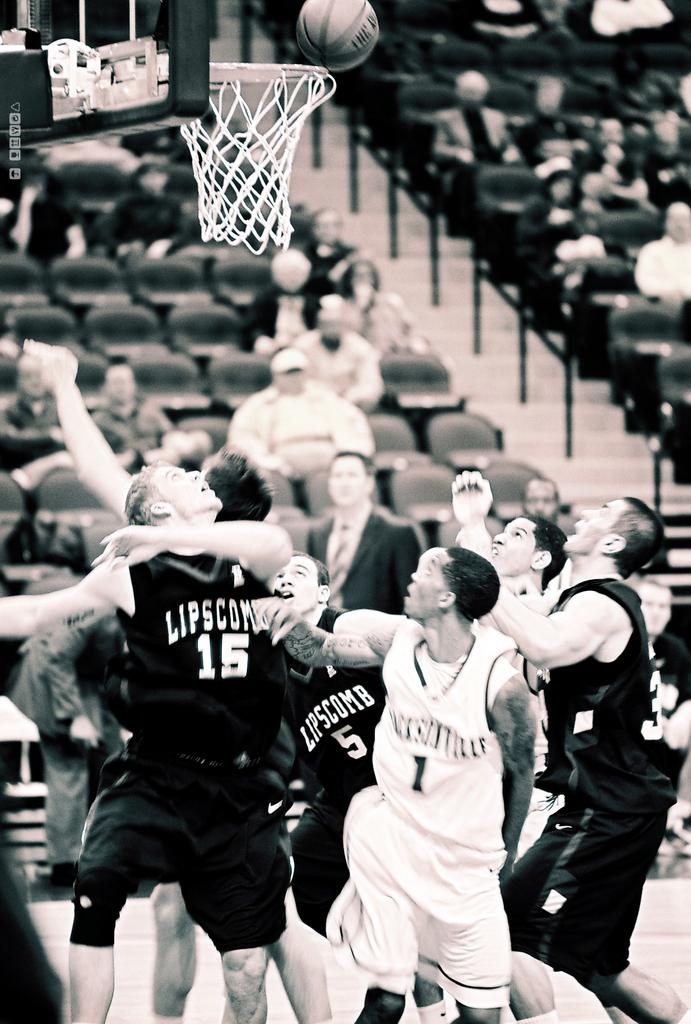What activity are the people in the image engaged in? The group of players in the image are engaged in a basketball game. Where are the players positioned in relation to the basketball net? The players are positioned under a basketball net. What is the current state of the basketball in the image? The basketball is above the net. How is the background of the players depicted in the image? The background of the players is blurred. What type of attack is being launched by the tank in the image? There is no tank present in the image; it features a group of basketball players. Can you describe the tub that is visible in the image? There is no tub present in the image; it features a group of basketball players under a basketball net. 